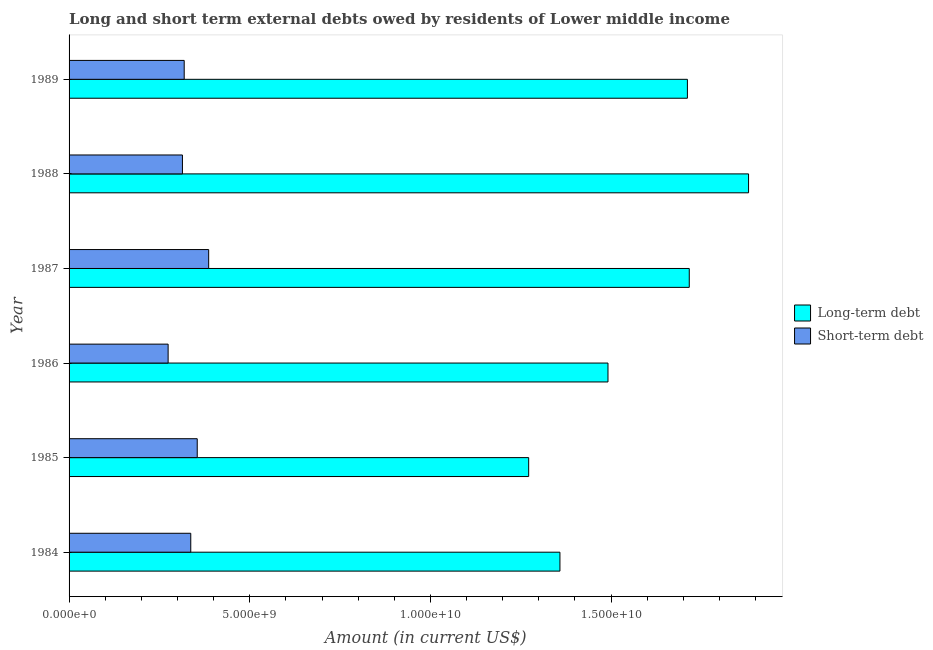How many groups of bars are there?
Provide a succinct answer. 6. Are the number of bars per tick equal to the number of legend labels?
Ensure brevity in your answer.  Yes. What is the long-term debts owed by residents in 1985?
Offer a very short reply. 1.27e+1. Across all years, what is the maximum long-term debts owed by residents?
Provide a succinct answer. 1.88e+1. Across all years, what is the minimum short-term debts owed by residents?
Provide a short and direct response. 2.74e+09. What is the total long-term debts owed by residents in the graph?
Your answer should be compact. 9.43e+1. What is the difference between the long-term debts owed by residents in 1985 and that in 1987?
Your answer should be compact. -4.44e+09. What is the difference between the short-term debts owed by residents in 1986 and the long-term debts owed by residents in 1985?
Give a very brief answer. -9.98e+09. What is the average long-term debts owed by residents per year?
Your answer should be very brief. 1.57e+1. In the year 1986, what is the difference between the long-term debts owed by residents and short-term debts owed by residents?
Your answer should be very brief. 1.22e+1. In how many years, is the short-term debts owed by residents greater than 9000000000 US$?
Offer a terse response. 0. What is the ratio of the short-term debts owed by residents in 1986 to that in 1989?
Keep it short and to the point. 0.86. Is the short-term debts owed by residents in 1984 less than that in 1985?
Provide a succinct answer. Yes. What is the difference between the highest and the second highest long-term debts owed by residents?
Provide a succinct answer. 1.64e+09. What is the difference between the highest and the lowest long-term debts owed by residents?
Provide a succinct answer. 6.09e+09. In how many years, is the long-term debts owed by residents greater than the average long-term debts owed by residents taken over all years?
Offer a very short reply. 3. Is the sum of the short-term debts owed by residents in 1988 and 1989 greater than the maximum long-term debts owed by residents across all years?
Provide a succinct answer. No. What does the 2nd bar from the top in 1987 represents?
Offer a terse response. Long-term debt. What does the 1st bar from the bottom in 1987 represents?
Ensure brevity in your answer.  Long-term debt. How many bars are there?
Make the answer very short. 12. How many years are there in the graph?
Make the answer very short. 6. What is the difference between two consecutive major ticks on the X-axis?
Ensure brevity in your answer.  5.00e+09. Are the values on the major ticks of X-axis written in scientific E-notation?
Your response must be concise. Yes. Where does the legend appear in the graph?
Offer a terse response. Center right. What is the title of the graph?
Keep it short and to the point. Long and short term external debts owed by residents of Lower middle income. What is the label or title of the X-axis?
Keep it short and to the point. Amount (in current US$). What is the label or title of the Y-axis?
Provide a succinct answer. Year. What is the Amount (in current US$) in Long-term debt in 1984?
Your answer should be very brief. 1.36e+1. What is the Amount (in current US$) in Short-term debt in 1984?
Your answer should be compact. 3.37e+09. What is the Amount (in current US$) in Long-term debt in 1985?
Offer a very short reply. 1.27e+1. What is the Amount (in current US$) in Short-term debt in 1985?
Keep it short and to the point. 3.55e+09. What is the Amount (in current US$) in Long-term debt in 1986?
Provide a succinct answer. 1.49e+1. What is the Amount (in current US$) in Short-term debt in 1986?
Your answer should be very brief. 2.74e+09. What is the Amount (in current US$) of Long-term debt in 1987?
Provide a succinct answer. 1.72e+1. What is the Amount (in current US$) of Short-term debt in 1987?
Make the answer very short. 3.86e+09. What is the Amount (in current US$) in Long-term debt in 1988?
Ensure brevity in your answer.  1.88e+1. What is the Amount (in current US$) in Short-term debt in 1988?
Give a very brief answer. 3.14e+09. What is the Amount (in current US$) of Long-term debt in 1989?
Ensure brevity in your answer.  1.71e+1. What is the Amount (in current US$) in Short-term debt in 1989?
Provide a short and direct response. 3.19e+09. Across all years, what is the maximum Amount (in current US$) in Long-term debt?
Make the answer very short. 1.88e+1. Across all years, what is the maximum Amount (in current US$) in Short-term debt?
Provide a succinct answer. 3.86e+09. Across all years, what is the minimum Amount (in current US$) of Long-term debt?
Your answer should be compact. 1.27e+1. Across all years, what is the minimum Amount (in current US$) of Short-term debt?
Provide a succinct answer. 2.74e+09. What is the total Amount (in current US$) of Long-term debt in the graph?
Your answer should be very brief. 9.43e+1. What is the total Amount (in current US$) of Short-term debt in the graph?
Provide a succinct answer. 1.98e+1. What is the difference between the Amount (in current US$) of Long-term debt in 1984 and that in 1985?
Your answer should be compact. 8.65e+08. What is the difference between the Amount (in current US$) in Short-term debt in 1984 and that in 1985?
Offer a very short reply. -1.79e+08. What is the difference between the Amount (in current US$) of Long-term debt in 1984 and that in 1986?
Give a very brief answer. -1.33e+09. What is the difference between the Amount (in current US$) in Short-term debt in 1984 and that in 1986?
Keep it short and to the point. 6.27e+08. What is the difference between the Amount (in current US$) of Long-term debt in 1984 and that in 1987?
Provide a succinct answer. -3.58e+09. What is the difference between the Amount (in current US$) of Short-term debt in 1984 and that in 1987?
Ensure brevity in your answer.  -4.95e+08. What is the difference between the Amount (in current US$) in Long-term debt in 1984 and that in 1988?
Offer a very short reply. -5.22e+09. What is the difference between the Amount (in current US$) in Short-term debt in 1984 and that in 1988?
Provide a short and direct response. 2.31e+08. What is the difference between the Amount (in current US$) in Long-term debt in 1984 and that in 1989?
Offer a very short reply. -3.53e+09. What is the difference between the Amount (in current US$) of Short-term debt in 1984 and that in 1989?
Provide a short and direct response. 1.82e+08. What is the difference between the Amount (in current US$) in Long-term debt in 1985 and that in 1986?
Your answer should be very brief. -2.19e+09. What is the difference between the Amount (in current US$) in Short-term debt in 1985 and that in 1986?
Your answer should be compact. 8.05e+08. What is the difference between the Amount (in current US$) in Long-term debt in 1985 and that in 1987?
Provide a succinct answer. -4.44e+09. What is the difference between the Amount (in current US$) in Short-term debt in 1985 and that in 1987?
Your answer should be very brief. -3.17e+08. What is the difference between the Amount (in current US$) of Long-term debt in 1985 and that in 1988?
Provide a short and direct response. -6.09e+09. What is the difference between the Amount (in current US$) in Short-term debt in 1985 and that in 1988?
Provide a short and direct response. 4.09e+08. What is the difference between the Amount (in current US$) in Long-term debt in 1985 and that in 1989?
Offer a very short reply. -4.39e+09. What is the difference between the Amount (in current US$) of Short-term debt in 1985 and that in 1989?
Offer a terse response. 3.61e+08. What is the difference between the Amount (in current US$) of Long-term debt in 1986 and that in 1987?
Give a very brief answer. -2.25e+09. What is the difference between the Amount (in current US$) of Short-term debt in 1986 and that in 1987?
Your response must be concise. -1.12e+09. What is the difference between the Amount (in current US$) in Long-term debt in 1986 and that in 1988?
Give a very brief answer. -3.89e+09. What is the difference between the Amount (in current US$) of Short-term debt in 1986 and that in 1988?
Provide a succinct answer. -3.96e+08. What is the difference between the Amount (in current US$) of Long-term debt in 1986 and that in 1989?
Provide a succinct answer. -2.20e+09. What is the difference between the Amount (in current US$) in Short-term debt in 1986 and that in 1989?
Offer a very short reply. -4.45e+08. What is the difference between the Amount (in current US$) of Long-term debt in 1987 and that in 1988?
Provide a succinct answer. -1.64e+09. What is the difference between the Amount (in current US$) in Short-term debt in 1987 and that in 1988?
Make the answer very short. 7.26e+08. What is the difference between the Amount (in current US$) in Long-term debt in 1987 and that in 1989?
Make the answer very short. 5.14e+07. What is the difference between the Amount (in current US$) in Short-term debt in 1987 and that in 1989?
Your answer should be very brief. 6.77e+08. What is the difference between the Amount (in current US$) in Long-term debt in 1988 and that in 1989?
Your answer should be compact. 1.69e+09. What is the difference between the Amount (in current US$) of Short-term debt in 1988 and that in 1989?
Provide a short and direct response. -4.88e+07. What is the difference between the Amount (in current US$) of Long-term debt in 1984 and the Amount (in current US$) of Short-term debt in 1985?
Make the answer very short. 1.00e+1. What is the difference between the Amount (in current US$) in Long-term debt in 1984 and the Amount (in current US$) in Short-term debt in 1986?
Give a very brief answer. 1.08e+1. What is the difference between the Amount (in current US$) of Long-term debt in 1984 and the Amount (in current US$) of Short-term debt in 1987?
Offer a very short reply. 9.72e+09. What is the difference between the Amount (in current US$) in Long-term debt in 1984 and the Amount (in current US$) in Short-term debt in 1988?
Offer a very short reply. 1.04e+1. What is the difference between the Amount (in current US$) in Long-term debt in 1984 and the Amount (in current US$) in Short-term debt in 1989?
Keep it short and to the point. 1.04e+1. What is the difference between the Amount (in current US$) in Long-term debt in 1985 and the Amount (in current US$) in Short-term debt in 1986?
Make the answer very short. 9.98e+09. What is the difference between the Amount (in current US$) in Long-term debt in 1985 and the Amount (in current US$) in Short-term debt in 1987?
Keep it short and to the point. 8.86e+09. What is the difference between the Amount (in current US$) of Long-term debt in 1985 and the Amount (in current US$) of Short-term debt in 1988?
Your answer should be very brief. 9.58e+09. What is the difference between the Amount (in current US$) of Long-term debt in 1985 and the Amount (in current US$) of Short-term debt in 1989?
Give a very brief answer. 9.53e+09. What is the difference between the Amount (in current US$) in Long-term debt in 1986 and the Amount (in current US$) in Short-term debt in 1987?
Your answer should be compact. 1.11e+1. What is the difference between the Amount (in current US$) of Long-term debt in 1986 and the Amount (in current US$) of Short-term debt in 1988?
Your response must be concise. 1.18e+1. What is the difference between the Amount (in current US$) in Long-term debt in 1986 and the Amount (in current US$) in Short-term debt in 1989?
Keep it short and to the point. 1.17e+1. What is the difference between the Amount (in current US$) in Long-term debt in 1987 and the Amount (in current US$) in Short-term debt in 1988?
Give a very brief answer. 1.40e+1. What is the difference between the Amount (in current US$) of Long-term debt in 1987 and the Amount (in current US$) of Short-term debt in 1989?
Your response must be concise. 1.40e+1. What is the difference between the Amount (in current US$) in Long-term debt in 1988 and the Amount (in current US$) in Short-term debt in 1989?
Make the answer very short. 1.56e+1. What is the average Amount (in current US$) in Long-term debt per year?
Your answer should be compact. 1.57e+1. What is the average Amount (in current US$) of Short-term debt per year?
Keep it short and to the point. 3.31e+09. In the year 1984, what is the difference between the Amount (in current US$) of Long-term debt and Amount (in current US$) of Short-term debt?
Your response must be concise. 1.02e+1. In the year 1985, what is the difference between the Amount (in current US$) in Long-term debt and Amount (in current US$) in Short-term debt?
Offer a very short reply. 9.17e+09. In the year 1986, what is the difference between the Amount (in current US$) in Long-term debt and Amount (in current US$) in Short-term debt?
Offer a very short reply. 1.22e+1. In the year 1987, what is the difference between the Amount (in current US$) in Long-term debt and Amount (in current US$) in Short-term debt?
Your answer should be compact. 1.33e+1. In the year 1988, what is the difference between the Amount (in current US$) in Long-term debt and Amount (in current US$) in Short-term debt?
Provide a succinct answer. 1.57e+1. In the year 1989, what is the difference between the Amount (in current US$) in Long-term debt and Amount (in current US$) in Short-term debt?
Your answer should be compact. 1.39e+1. What is the ratio of the Amount (in current US$) of Long-term debt in 1984 to that in 1985?
Ensure brevity in your answer.  1.07. What is the ratio of the Amount (in current US$) in Short-term debt in 1984 to that in 1985?
Your response must be concise. 0.95. What is the ratio of the Amount (in current US$) in Long-term debt in 1984 to that in 1986?
Your answer should be compact. 0.91. What is the ratio of the Amount (in current US$) of Short-term debt in 1984 to that in 1986?
Make the answer very short. 1.23. What is the ratio of the Amount (in current US$) in Long-term debt in 1984 to that in 1987?
Offer a terse response. 0.79. What is the ratio of the Amount (in current US$) of Short-term debt in 1984 to that in 1987?
Give a very brief answer. 0.87. What is the ratio of the Amount (in current US$) of Long-term debt in 1984 to that in 1988?
Give a very brief answer. 0.72. What is the ratio of the Amount (in current US$) of Short-term debt in 1984 to that in 1988?
Your response must be concise. 1.07. What is the ratio of the Amount (in current US$) of Long-term debt in 1984 to that in 1989?
Keep it short and to the point. 0.79. What is the ratio of the Amount (in current US$) of Short-term debt in 1984 to that in 1989?
Keep it short and to the point. 1.06. What is the ratio of the Amount (in current US$) in Long-term debt in 1985 to that in 1986?
Your response must be concise. 0.85. What is the ratio of the Amount (in current US$) in Short-term debt in 1985 to that in 1986?
Keep it short and to the point. 1.29. What is the ratio of the Amount (in current US$) of Long-term debt in 1985 to that in 1987?
Ensure brevity in your answer.  0.74. What is the ratio of the Amount (in current US$) in Short-term debt in 1985 to that in 1987?
Your response must be concise. 0.92. What is the ratio of the Amount (in current US$) of Long-term debt in 1985 to that in 1988?
Keep it short and to the point. 0.68. What is the ratio of the Amount (in current US$) of Short-term debt in 1985 to that in 1988?
Offer a terse response. 1.13. What is the ratio of the Amount (in current US$) of Long-term debt in 1985 to that in 1989?
Your answer should be compact. 0.74. What is the ratio of the Amount (in current US$) of Short-term debt in 1985 to that in 1989?
Your response must be concise. 1.11. What is the ratio of the Amount (in current US$) of Long-term debt in 1986 to that in 1987?
Keep it short and to the point. 0.87. What is the ratio of the Amount (in current US$) of Short-term debt in 1986 to that in 1987?
Provide a succinct answer. 0.71. What is the ratio of the Amount (in current US$) of Long-term debt in 1986 to that in 1988?
Offer a terse response. 0.79. What is the ratio of the Amount (in current US$) of Short-term debt in 1986 to that in 1988?
Provide a succinct answer. 0.87. What is the ratio of the Amount (in current US$) in Long-term debt in 1986 to that in 1989?
Your answer should be very brief. 0.87. What is the ratio of the Amount (in current US$) in Short-term debt in 1986 to that in 1989?
Give a very brief answer. 0.86. What is the ratio of the Amount (in current US$) of Long-term debt in 1987 to that in 1988?
Give a very brief answer. 0.91. What is the ratio of the Amount (in current US$) of Short-term debt in 1987 to that in 1988?
Make the answer very short. 1.23. What is the ratio of the Amount (in current US$) of Short-term debt in 1987 to that in 1989?
Your answer should be compact. 1.21. What is the ratio of the Amount (in current US$) in Long-term debt in 1988 to that in 1989?
Keep it short and to the point. 1.1. What is the ratio of the Amount (in current US$) of Short-term debt in 1988 to that in 1989?
Your response must be concise. 0.98. What is the difference between the highest and the second highest Amount (in current US$) in Long-term debt?
Provide a succinct answer. 1.64e+09. What is the difference between the highest and the second highest Amount (in current US$) in Short-term debt?
Your answer should be very brief. 3.17e+08. What is the difference between the highest and the lowest Amount (in current US$) in Long-term debt?
Your response must be concise. 6.09e+09. What is the difference between the highest and the lowest Amount (in current US$) in Short-term debt?
Make the answer very short. 1.12e+09. 